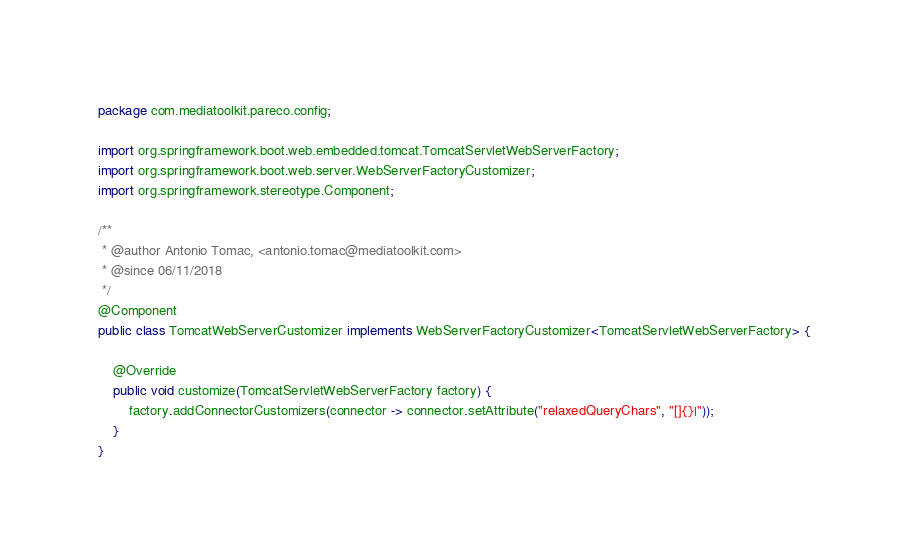Convert code to text. <code><loc_0><loc_0><loc_500><loc_500><_Java_>package com.mediatoolkit.pareco.config;

import org.springframework.boot.web.embedded.tomcat.TomcatServletWebServerFactory;
import org.springframework.boot.web.server.WebServerFactoryCustomizer;
import org.springframework.stereotype.Component;

/**
 * @author Antonio Tomac, <antonio.tomac@mediatoolkit.com>
 * @since 06/11/2018
 */
@Component
public class TomcatWebServerCustomizer implements WebServerFactoryCustomizer<TomcatServletWebServerFactory> {

	@Override
	public void customize(TomcatServletWebServerFactory factory) {
		factory.addConnectorCustomizers(connector -> connector.setAttribute("relaxedQueryChars", "[]{}|"));
	}
}
</code> 